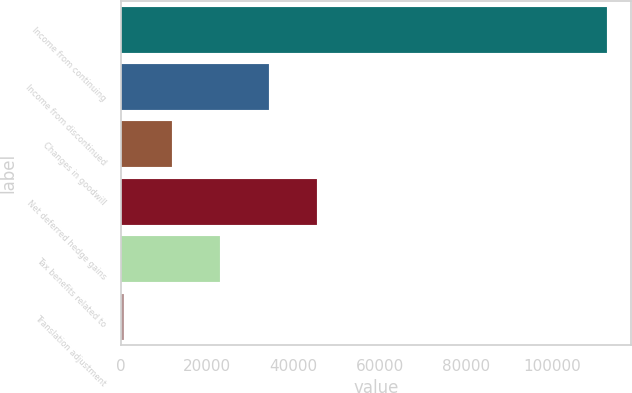<chart> <loc_0><loc_0><loc_500><loc_500><bar_chart><fcel>Income from continuing<fcel>Income from discontinued<fcel>Changes in goodwill<fcel>Net deferred hedge gains<fcel>Tax benefits related to<fcel>Translation adjustment<nl><fcel>112645<fcel>34244.3<fcel>11844.1<fcel>45444.4<fcel>23044.2<fcel>644<nl></chart> 